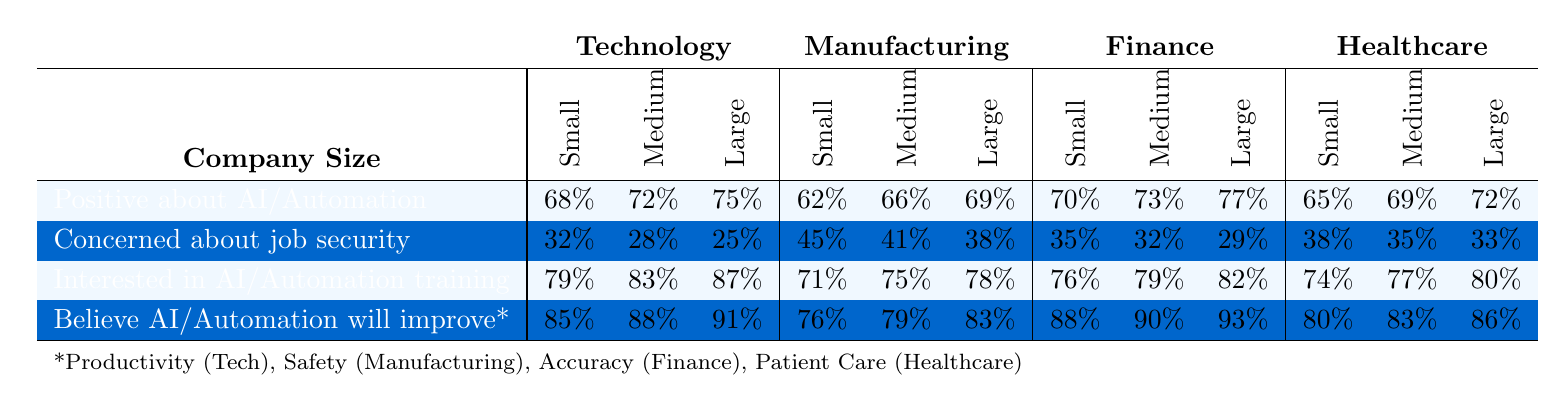What percentage of employees in the healthcare industry believe AI will improve patient care? In the healthcare row, under the large company size category, the percentage of employees who believe AI will improve patient care is 86%.
Answer: 86% What is the percentage of employees in large companies in the finance industry who are concerned about job security? Looking at the finance row under large company size, the percentage of employees concerned about job security is 29%.
Answer: 29% In which industry do small company employees show the highest percentage of positive attitudes towards AI or automation? By comparing the positive attitudes in the small company size across industries, Technology shows the highest at 68%, while Manufacturing, Finance, and Healthcare show 62%, 70%, and 65% respectively.
Answer: Technology What is the difference in the percentage of employees who are interested in AI training between medium-sized companies in the technology and healthcare industries? For medium company sizes, employees interested in AI training in Technology is 83% and in Healthcare is 77%. The difference is 83% - 77% = 6%.
Answer: 6% Are employees in medium-sized companies across all industries generally more positive about AI/automation than those in small companies? By comparing the percentages of positive attitudes in medium vs small companies: Technology (72% vs 68%), Manufacturing (66% vs 62%), Finance (73% vs 70%), Healthcare (69% vs 65%). All medium percentages are greater than the small percentages, confirming the statement as true.
Answer: Yes What is the average percentage of employees who believe AI will improve productivity in large companies across all industries? The percentages for large companies are: Technology 91%, Manufacturing 83%, Finance 93%, and Healthcare 86%. Adding these values gives 91 + 83 + 93 + 86 = 353. With 4 industries, the average is 353 / 4 = 88.25%.
Answer: 88.25% Which company size in the manufacturing industry has the highest percentage of employees believing that automation will improve safety? From the manufacturing row, the percentages for small, medium, and large companies are 76%, 79%, and 83%, respectively. Therefore, large companies have the highest percentage at 83%.
Answer: Large (500+ employees) In which industry do large companies have the greatest concern about job security? The percentages for job security concern in large companies are: Technology (25%), Manufacturing (38%), Finance (29%), and Healthcare (33%). The highest concern is in Manufacturing at 38%.
Answer: Manufacturing 